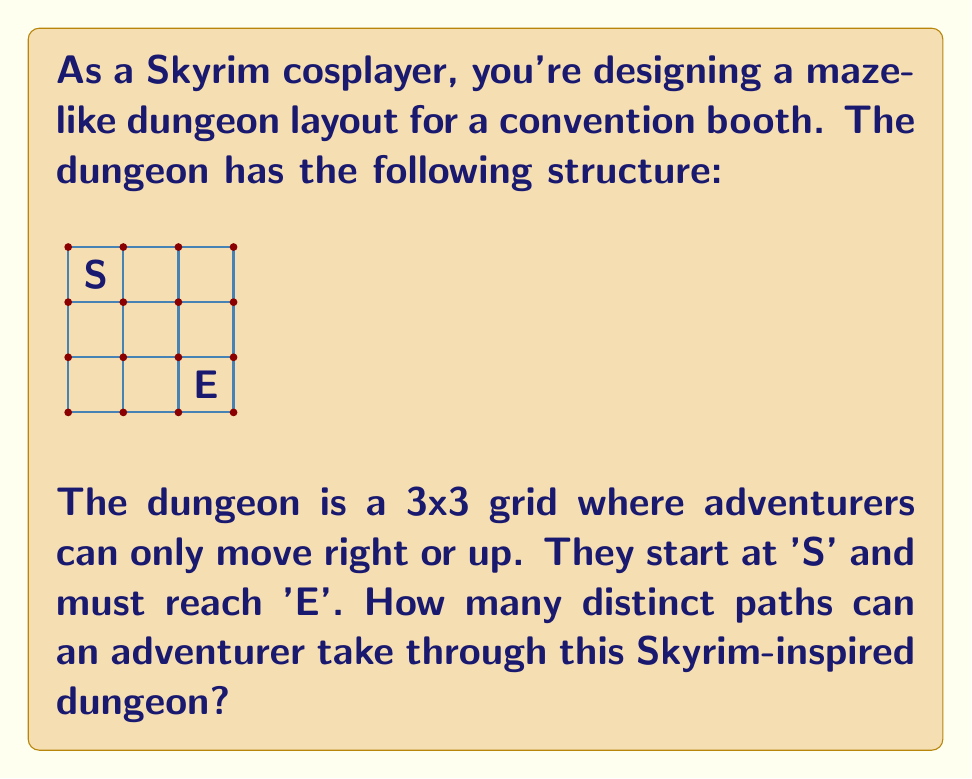Help me with this question. Let's approach this step-by-step:

1) First, we need to understand what the question is asking. We're looking for the number of distinct paths from the bottom-left corner (S) to the top-right corner (E) of a 3x3 grid, moving only right or up.

2) This is a classic combinatorics problem. To reach E from S, an adventurer must move 2 steps right and 2 steps up, in any order.

3) The total number of steps is always 4 (2 right + 2 up).

4) The question is essentially asking: "In how many ways can we arrange 2 right moves and 2 up moves?"

5) This is equivalent to choosing the positions for the right moves (or the up moves) out of the 4 total moves.

6) We can solve this using the combination formula:

   $$\binom{4}{2} = \frac{4!}{2!(4-2)!} = \frac{4!}{2!2!}$$

7) Let's calculate:
   $$\frac{4 * 3 * 2 * 1}{(2 * 1)(2 * 1)} = \frac{24}{4} = 6$$

Therefore, there are 6 distinct paths through the dungeon.
Answer: 6 